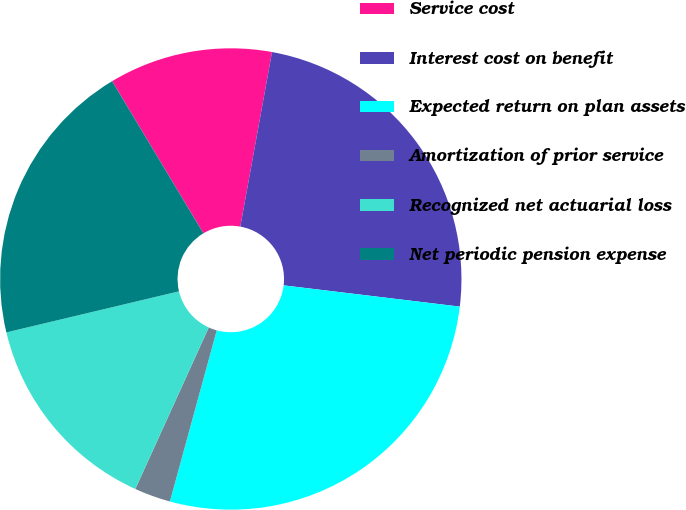<chart> <loc_0><loc_0><loc_500><loc_500><pie_chart><fcel>Service cost<fcel>Interest cost on benefit<fcel>Expected return on plan assets<fcel>Amortization of prior service<fcel>Recognized net actuarial loss<fcel>Net periodic pension expense<nl><fcel>11.46%<fcel>24.05%<fcel>27.34%<fcel>2.54%<fcel>14.49%<fcel>20.12%<nl></chart> 